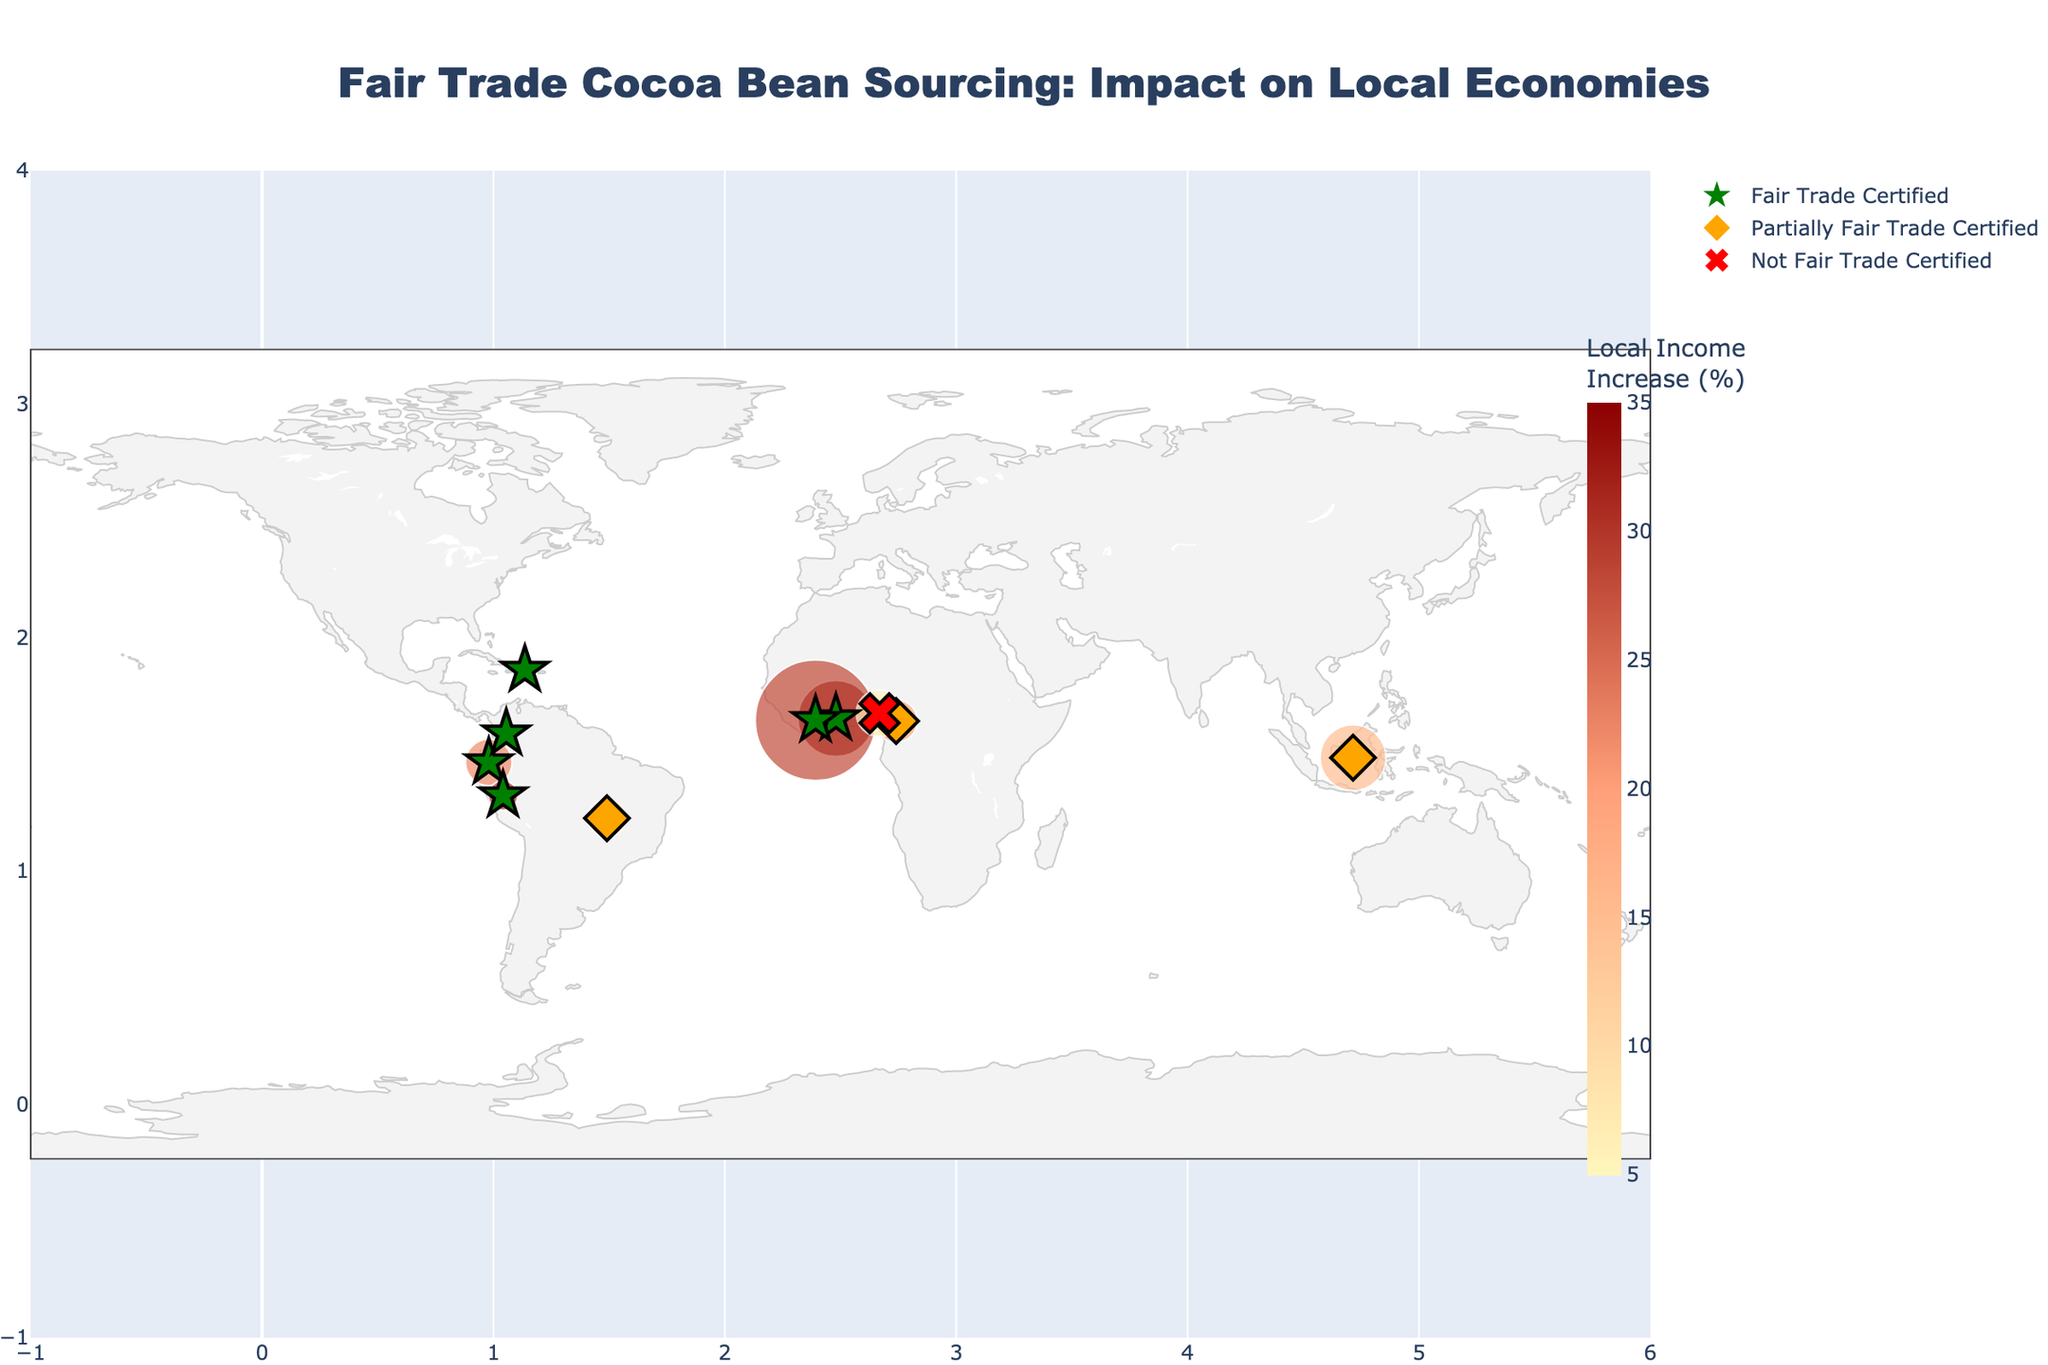How many countries in the dataset are Fair Trade Certified? Look for the markers indicating Fair Trade Certification. There are symbols for Fair Trade Certified, Partially Fair Trade Certified, and Not Fair Trade Certified. Count only the countries with the 'star' symbol, which indicates full certification.
Answer: 6 Which country has the highest local income increase percentage? Observe the color scale representing the local income increase percentages. Identify which country marker is the darkest, as darker colors represent higher percentages.
Answer: Ghana What is the approximate ratio of annual cocoa production between Ghana and Nigeria? Check the sizes of the markers corresponding to Ghana and Nigeria, which indicate cocoa production. Ghana has a production of 800,000 tons while Nigeria has 300,000 tons. The ratio is 800,000:300,000, which simplifies to approximately 8:3.
Answer: 8:3 How many jobs were created in countries with full Fair Trade certification? Identify the countries with full Fair Trade certification (marked by a green star) and sum the 'Jobs_Created' values for these countries: Ghana (12,000), Côte d'Ivoire (18,000), Ecuador (5,000), Peru (3,500), Dominican Republic (2,000), Colombia (1,500). Calculation: 12,000 + 18,000 + 5,000 + 3,500 + 2,000 + 1,500 = 42,000.
Answer: 42,000 Which country with partial Fair Trade certification has the highest percentage increase in local income? Look for countries marked with an orange diamond, which indicates partial Fair Trade certification. Compare their color intensities to measure the local income increase. Indonesia (15%), Cameroon (18%), Brazil (12%). Cameroon has the highest percentage.
Answer: Cameroon What is the total annual cocoa production of countries not Fair Trade certified? Identify countries not Fair Trade certified (marked by a red 'x') and sum their cocoa production. Nigeria is the only such country with 300,000 tons of cocoa production.
Answer: 300,000 tons How does Côte d'Ivoire's local income increase percentage compare to that of Peru? Find Côte d'Ivoire and Peru on the map. Côte d'Ivoire has a local income increase of 28%, and Peru has 30%. Compare these two values.
Answer: Peru's percentage is higher If you were to average the annual cocoa production of fully Fair Trade Certified countries, what would it be? Sum the annual cocoa production for countries with full Fair Trade certification: Ghana (800,000), Côte d'Ivoire (2,000,000), Ecuador (300,000), Peru (120,000), Dominican Republic (80,000), Colombia (55,000). Total: 800,000 + 2,000,000 + 300,000 + 120,000 + 80,000 + 55,000 = 3,355,000 tons. Then, divide by the number of these countries, which is 6. 3,355,000 / 6 = 559,167 tons.
Answer: 559,167 tons What is the combined percentage increase in local income for Ecuador and Indonesia? Look at the local income increase percentages for Ecuador (22%) and Indonesia (15%). Add these two values together: 22% + 15% = 37%.
Answer: 37% Which country with Fair Trade certification is geographically closest to the equator? Identify the countries with Fair Trade certification marked by a green star. Check their latitudes to determine which is closest to zero. Ecuador has a latitude of -1.8312, closest to the equator.
Answer: Ecuador 